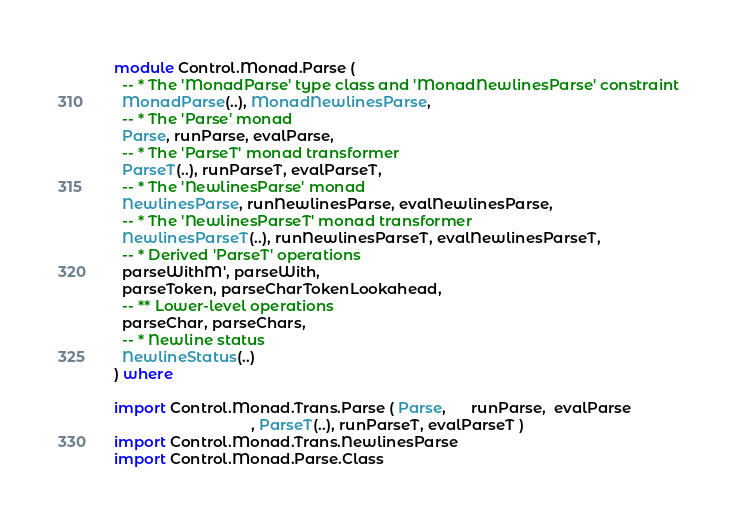<code> <loc_0><loc_0><loc_500><loc_500><_Haskell_>module Control.Monad.Parse (
  -- * The 'MonadParse' type class and 'MonadNewlinesParse' constraint
  MonadParse(..), MonadNewlinesParse,
  -- * The 'Parse' monad
  Parse, runParse, evalParse,
  -- * The 'ParseT' monad transformer
  ParseT(..), runParseT, evalParseT,
  -- * The 'NewlinesParse' monad
  NewlinesParse, runNewlinesParse, evalNewlinesParse,
  -- * The 'NewlinesParseT' monad transformer
  NewlinesParseT(..), runNewlinesParseT, evalNewlinesParseT,
  -- * Derived 'ParseT' operations
  parseWithM', parseWith,
  parseToken, parseCharTokenLookahead,
  -- ** Lower-level operations
  parseChar, parseChars,
  -- * Newline status
  NewlineStatus(..)
) where

import Control.Monad.Trans.Parse ( Parse,      runParse,  evalParse
                                 , ParseT(..), runParseT, evalParseT )
import Control.Monad.Trans.NewlinesParse
import Control.Monad.Parse.Class
</code> 